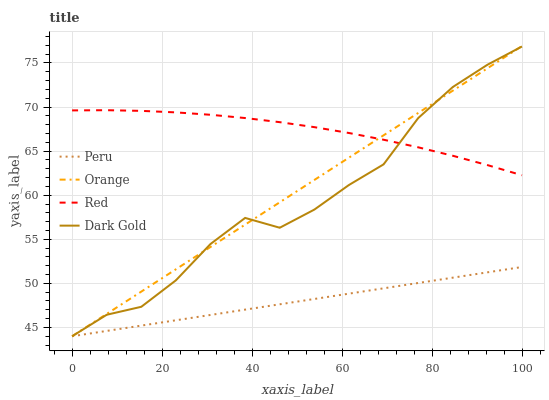Does Peru have the minimum area under the curve?
Answer yes or no. Yes. Does Red have the maximum area under the curve?
Answer yes or no. Yes. Does Red have the minimum area under the curve?
Answer yes or no. No. Does Peru have the maximum area under the curve?
Answer yes or no. No. Is Peru the smoothest?
Answer yes or no. Yes. Is Dark Gold the roughest?
Answer yes or no. Yes. Is Red the smoothest?
Answer yes or no. No. Is Red the roughest?
Answer yes or no. No. Does Orange have the lowest value?
Answer yes or no. Yes. Does Red have the lowest value?
Answer yes or no. No. Does Orange have the highest value?
Answer yes or no. Yes. Does Red have the highest value?
Answer yes or no. No. Is Peru less than Red?
Answer yes or no. Yes. Is Red greater than Peru?
Answer yes or no. Yes. Does Orange intersect Dark Gold?
Answer yes or no. Yes. Is Orange less than Dark Gold?
Answer yes or no. No. Is Orange greater than Dark Gold?
Answer yes or no. No. Does Peru intersect Red?
Answer yes or no. No. 